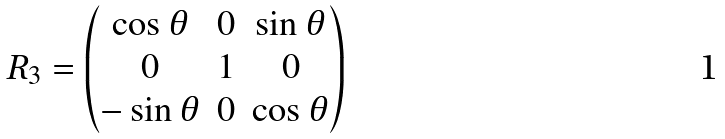<formula> <loc_0><loc_0><loc_500><loc_500>R _ { 3 } = \begin{pmatrix} \cos \theta & 0 & \sin \theta \\ 0 & 1 & 0 \\ - \sin \theta & 0 & \cos \theta \end{pmatrix}</formula> 